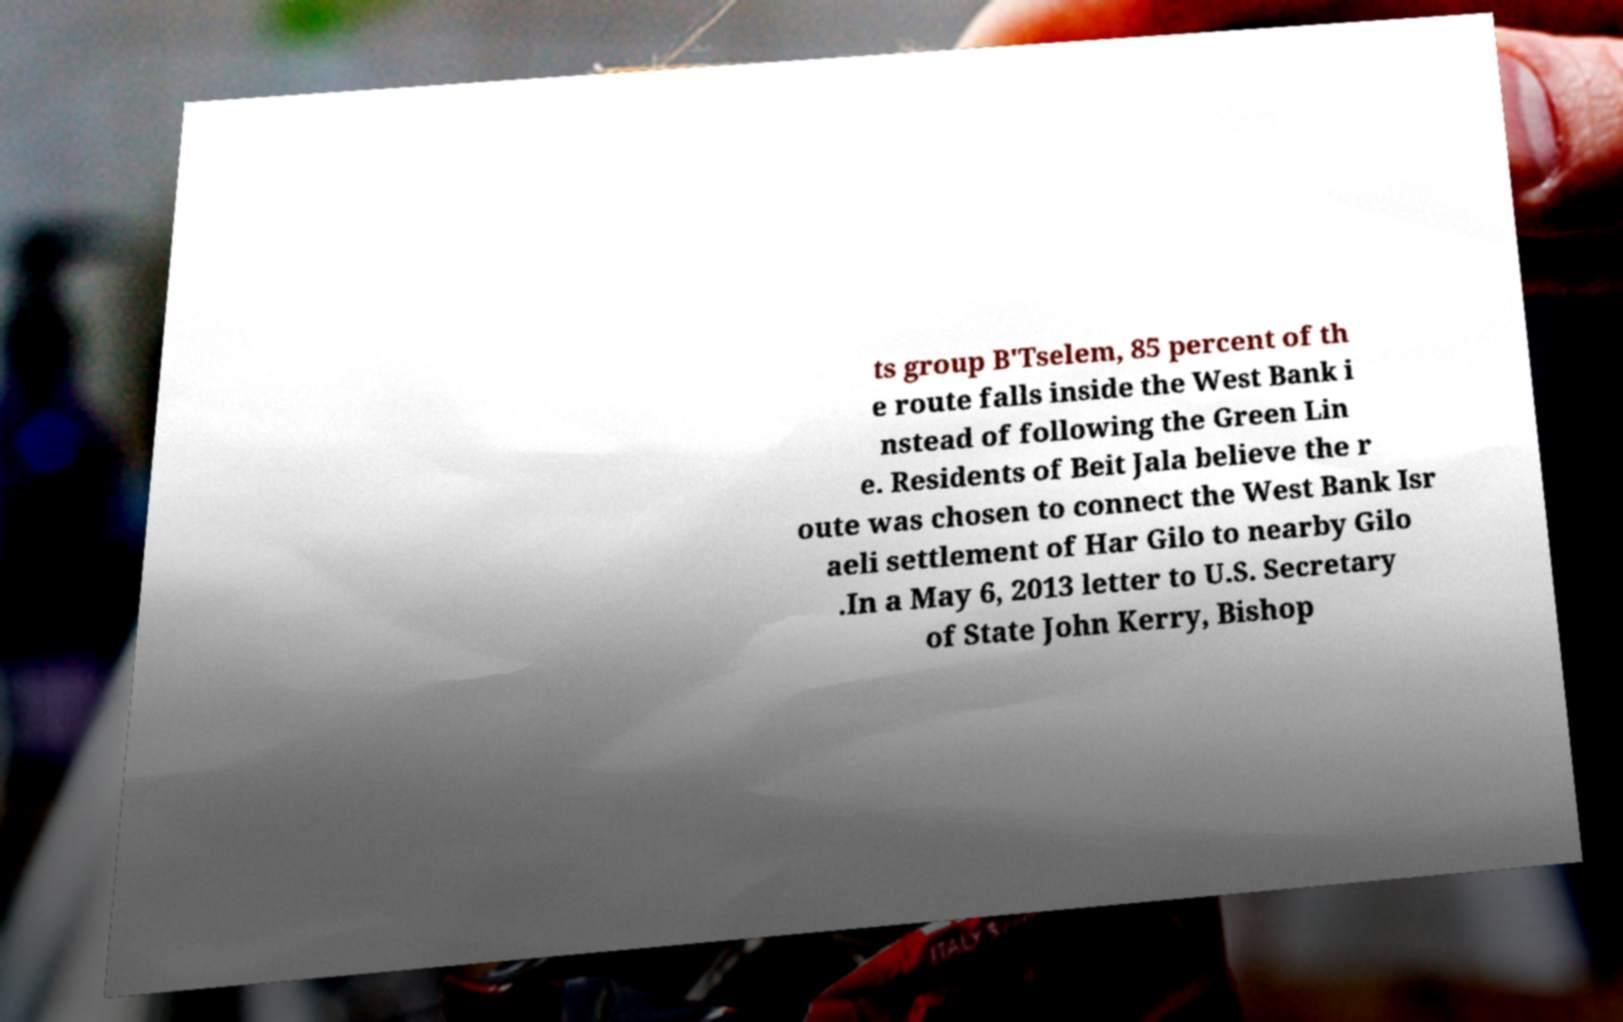Could you assist in decoding the text presented in this image and type it out clearly? ts group B'Tselem, 85 percent of th e route falls inside the West Bank i nstead of following the Green Lin e. Residents of Beit Jala believe the r oute was chosen to connect the West Bank Isr aeli settlement of Har Gilo to nearby Gilo .In a May 6, 2013 letter to U.S. Secretary of State John Kerry, Bishop 